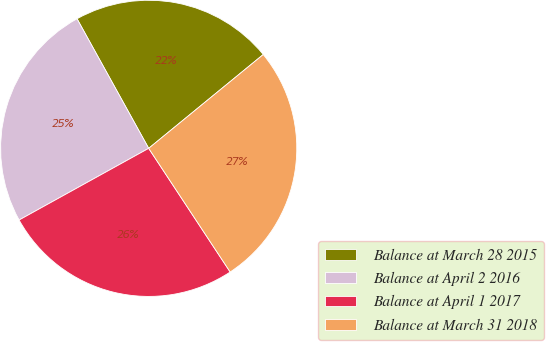Convert chart to OTSL. <chart><loc_0><loc_0><loc_500><loc_500><pie_chart><fcel>Balance at March 28 2015<fcel>Balance at April 2 2016<fcel>Balance at April 1 2017<fcel>Balance at March 31 2018<nl><fcel>22.12%<fcel>25.0%<fcel>26.23%<fcel>26.65%<nl></chart> 